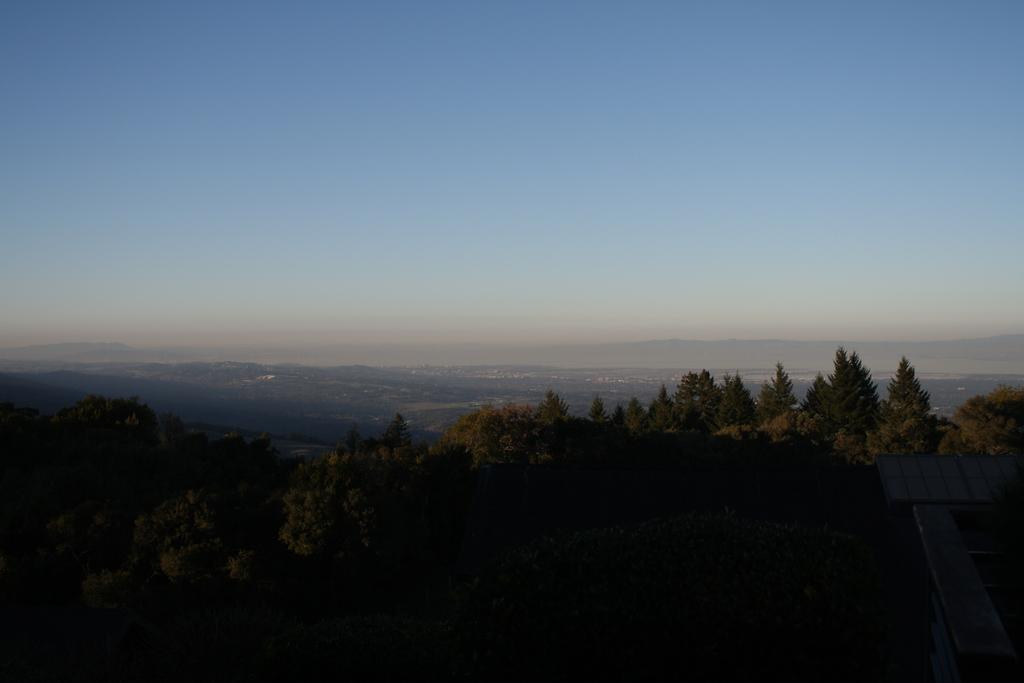Where was the image taken? The image was taken outside. What can be seen in the foreground of the image? There are trees and other objects in the foreground of the image. What is visible in the background of the image? The sky is visible in the background of the image, along with many other objects. Can you describe the stranger sitting on the seat in the image? There is no stranger or seat present in the image. What type of body is visible in the image? There is no body visible in the image; it features trees, other objects, and the sky. 